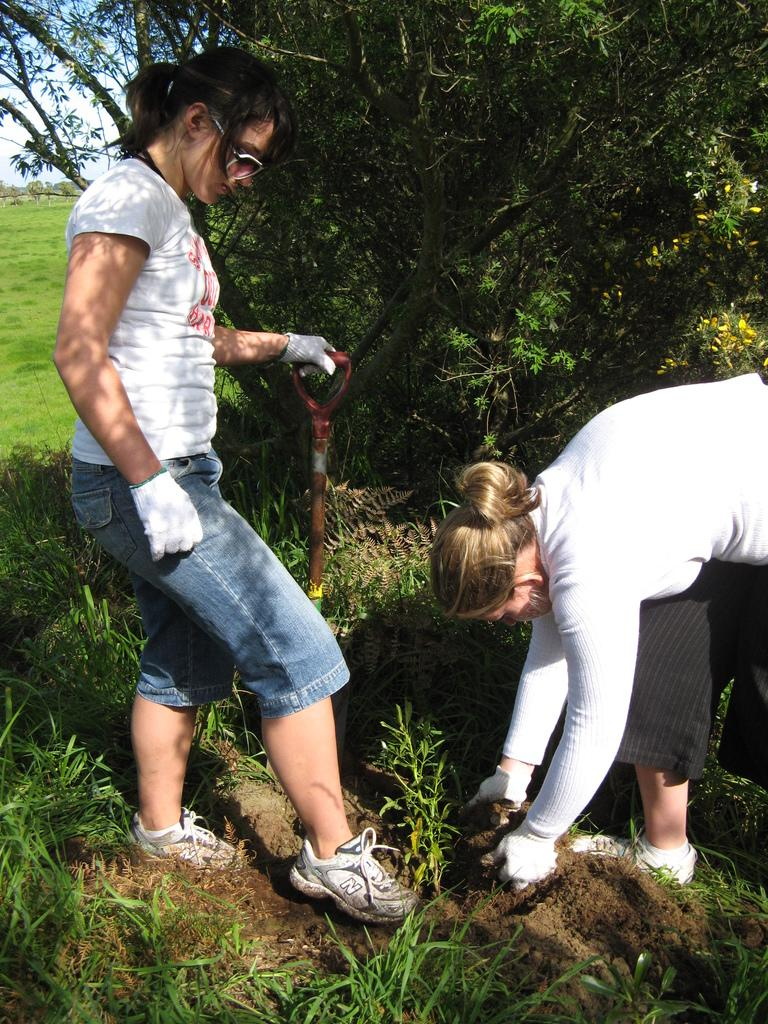How many girls are in the image? There are two girls in the image. Where are the girls positioned in the image? The girls are on the right and left sides of the image. What activity are the girls engaged in? The girls appear to be digging. What type of environment is depicted in the image? There is greenery around the area of the image. What language is the beggar speaking in the image? There is no beggar present in the image, so it is not possible to determine what language they might be speaking. 